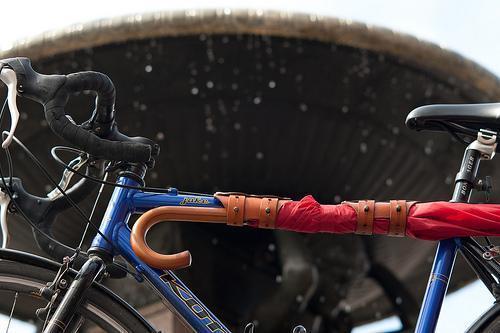How many bicycles are in the picture?
Give a very brief answer. 1. 